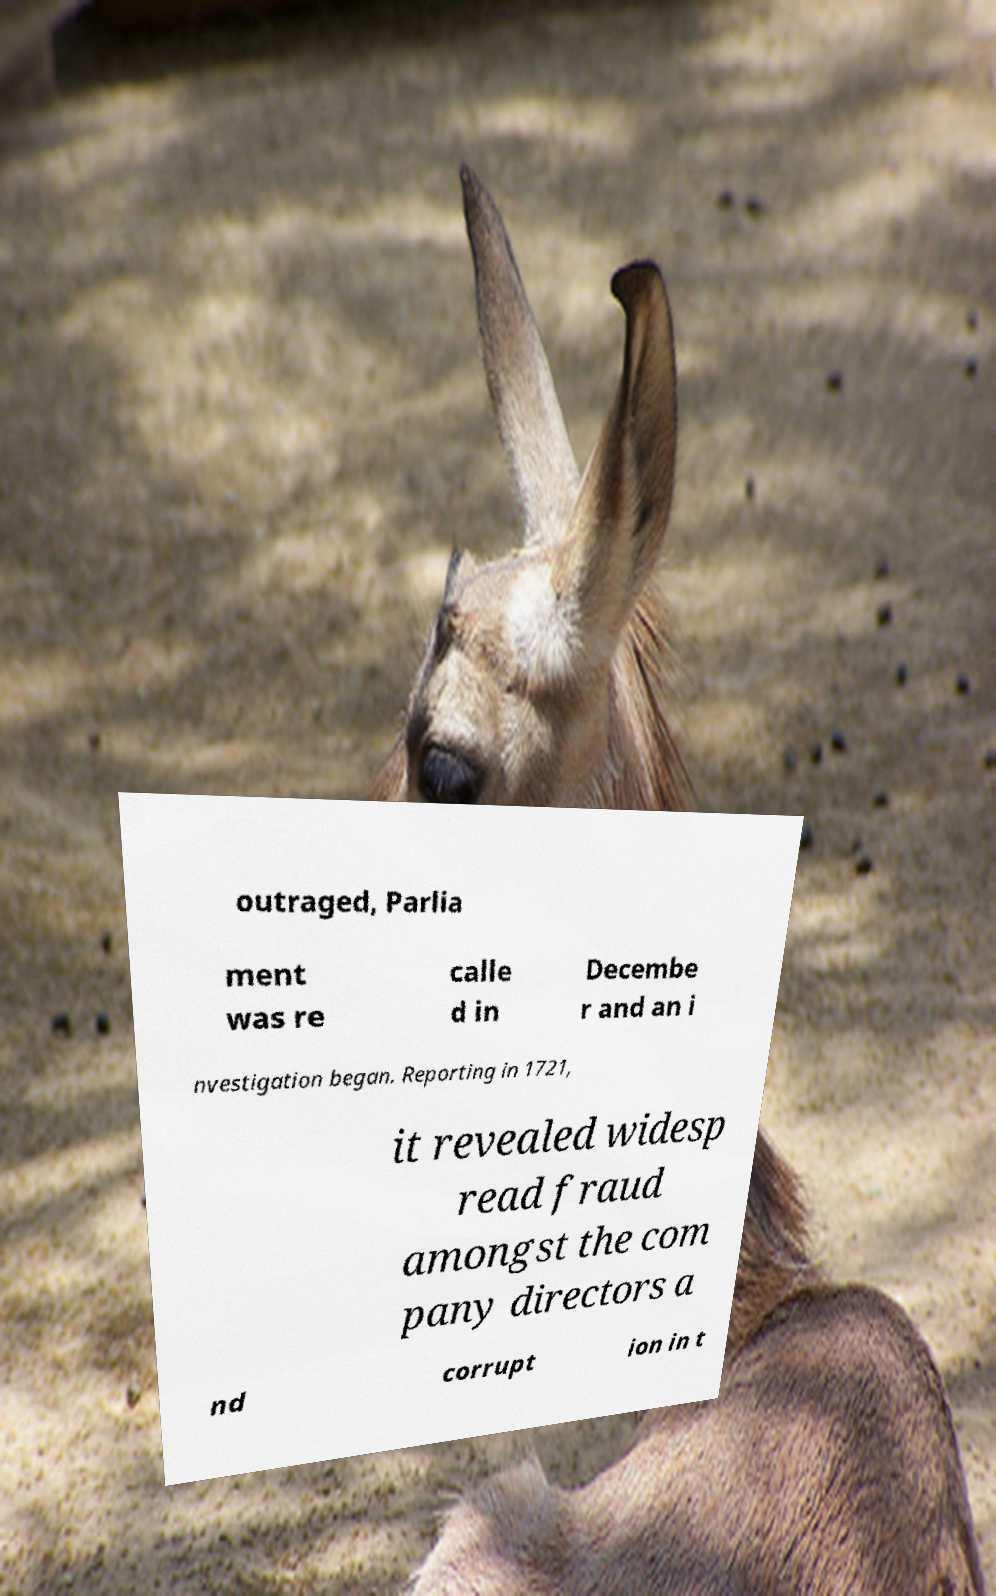Please read and relay the text visible in this image. What does it say? outraged, Parlia ment was re calle d in Decembe r and an i nvestigation began. Reporting in 1721, it revealed widesp read fraud amongst the com pany directors a nd corrupt ion in t 